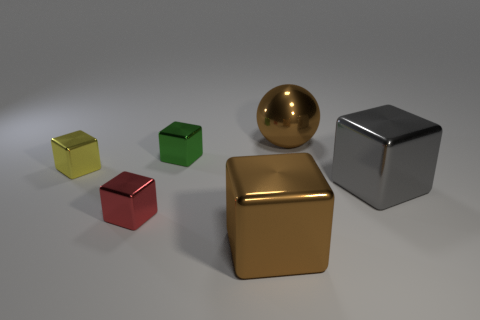Subtract all green cubes. How many cubes are left? 4 Subtract all tiny yellow blocks. How many blocks are left? 4 Subtract all purple cubes. Subtract all brown cylinders. How many cubes are left? 5 Add 1 tiny red things. How many objects exist? 7 Subtract all balls. How many objects are left? 5 Add 5 gray metal things. How many gray metal things are left? 6 Add 1 red metal blocks. How many red metal blocks exist? 2 Subtract 0 green cylinders. How many objects are left? 6 Subtract all tiny green blocks. Subtract all brown shiny spheres. How many objects are left? 4 